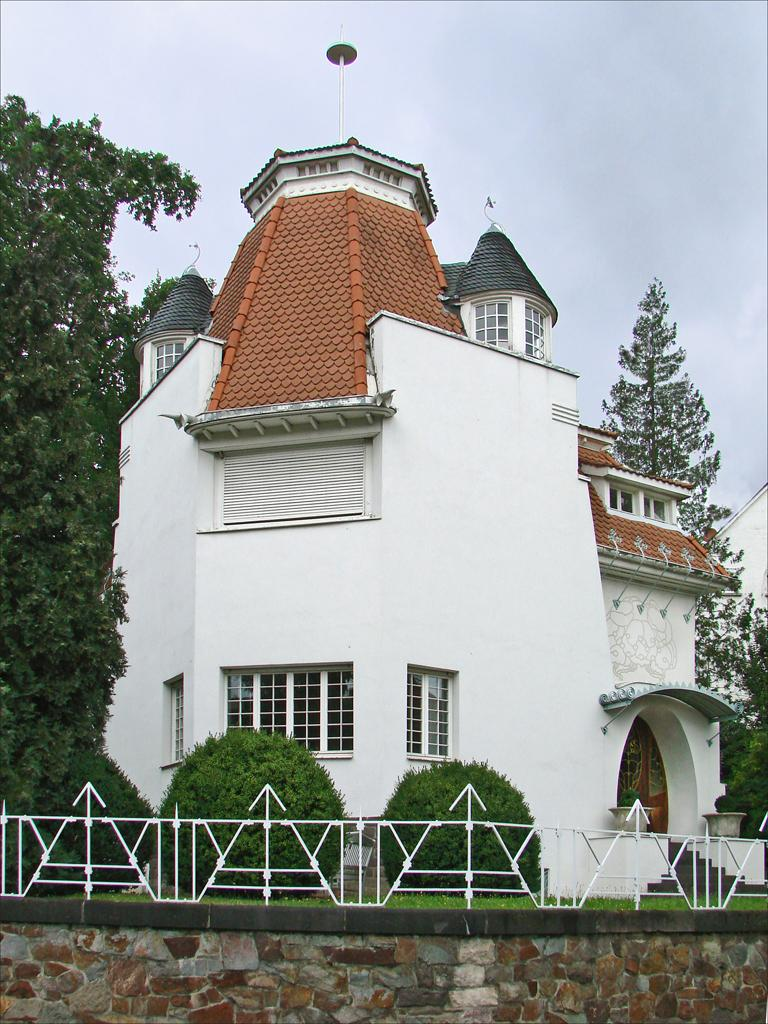What type of structure can be seen in the image? There is a building in the image. What type of barrier is present in the image? There is fencing in the image. What type of vertical surface is visible in the image? There is a wall in the image. What type of vegetation is present in the image? There is grass, bushes, and trees in the image. What part of the natural environment is visible in the image? The sky is visible in the background of the image. What type of fiction is being sold in the store in the image? There is no store present in the image, and therefore no fiction being sold. What position does the tree hold in the image? The question is unclear, but trees are not assigned positions in images. They are simply present in the image. 